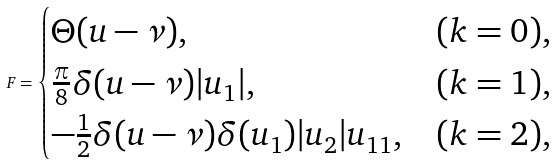Convert formula to latex. <formula><loc_0><loc_0><loc_500><loc_500>F = \begin{cases} \Theta ( u - \nu ) , & ( k = 0 ) , \\ \frac { \pi } { 8 } \delta ( u - \nu ) | u _ { 1 } | , & ( k = 1 ) , \\ - \frac { 1 } { 2 } \delta ( u - \nu ) \delta ( u _ { 1 } ) | u _ { 2 } | u _ { 1 1 } , & ( k = 2 ) , \end{cases}</formula> 